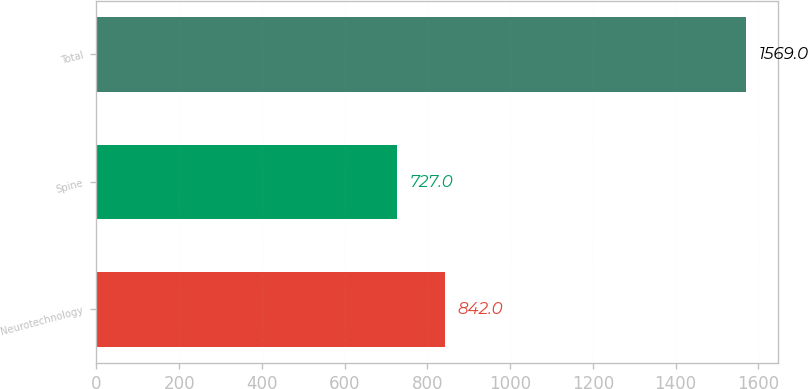Convert chart. <chart><loc_0><loc_0><loc_500><loc_500><bar_chart><fcel>Neurotechnology<fcel>Spine<fcel>Total<nl><fcel>842<fcel>727<fcel>1569<nl></chart> 